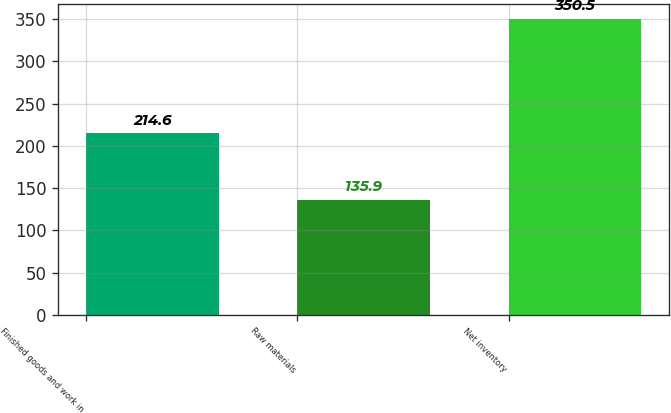Convert chart to OTSL. <chart><loc_0><loc_0><loc_500><loc_500><bar_chart><fcel>Finished goods and work in<fcel>Raw materials<fcel>Net inventory<nl><fcel>214.6<fcel>135.9<fcel>350.5<nl></chart> 